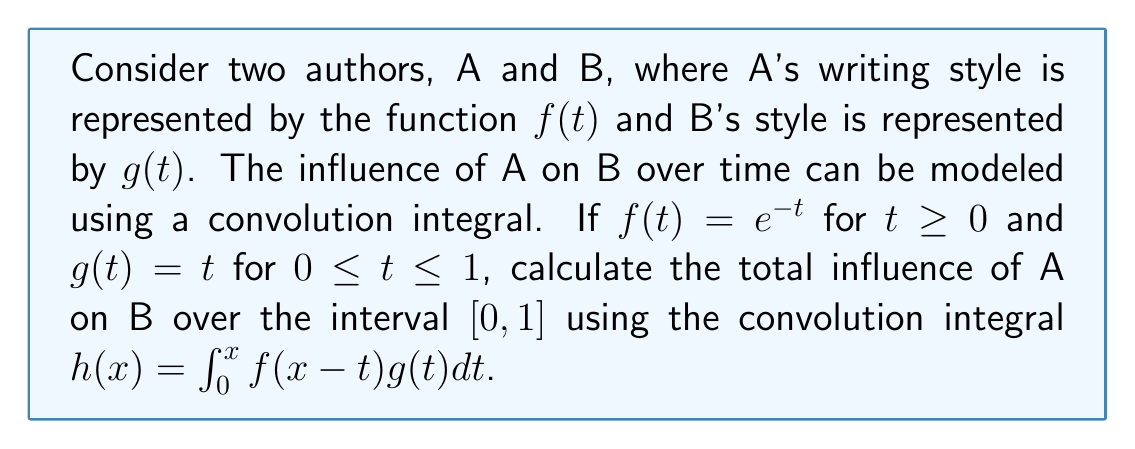Solve this math problem. 1) The convolution integral is given by:
   $$h(x) = \int_0^x f(x-t)g(t)dt$$

2) Substituting the given functions:
   $$h(x) = \int_0^x e^{-(x-t)}t dt$$

3) To find the total influence over $[0,1]$, we need to evaluate $h(1)$:
   $$h(1) = \int_0^1 e^{-(1-t)}t dt$$

4) Let $u = 1-t$, then $du = -dt$ and when $t = 0$, $u = 1$; when $t = 1$, $u = 0$:
   $$h(1) = -\int_1^0 e^{-u}(1-u) (-du) = \int_0^1 e^{-u}(1-u) du$$

5) Expand the integrand:
   $$h(1) = \int_0^1 (e^{-u} - ue^{-u}) du$$

6) Integrate term by term:
   $$h(1) = [-e^{-u}]_0^1 - [\int_0^1 ue^{-u} du]$$

7) For the second term, use integration by parts. Let $v = u$ and $dw = e^{-u}du$:
   $$h(1) = [-e^{-u}]_0^1 - [ue^{-u}]_0^1 + \int_0^1 e^{-u} du$$

8) Evaluate the definite integrals:
   $$h(1) = [-(e^{-1} - 1)] - [(1e^{-1} - 0)] + [-(e^{-1} - 1)]$$

9) Simplify:
   $$h(1) = -e^{-1} + 1 - e^{-1} + e^{-1} - 1 = -e^{-1}$$

Therefore, the total influence of A on B over the interval $[0,1]$ is $-e^{-1}$.
Answer: $-e^{-1}$ 